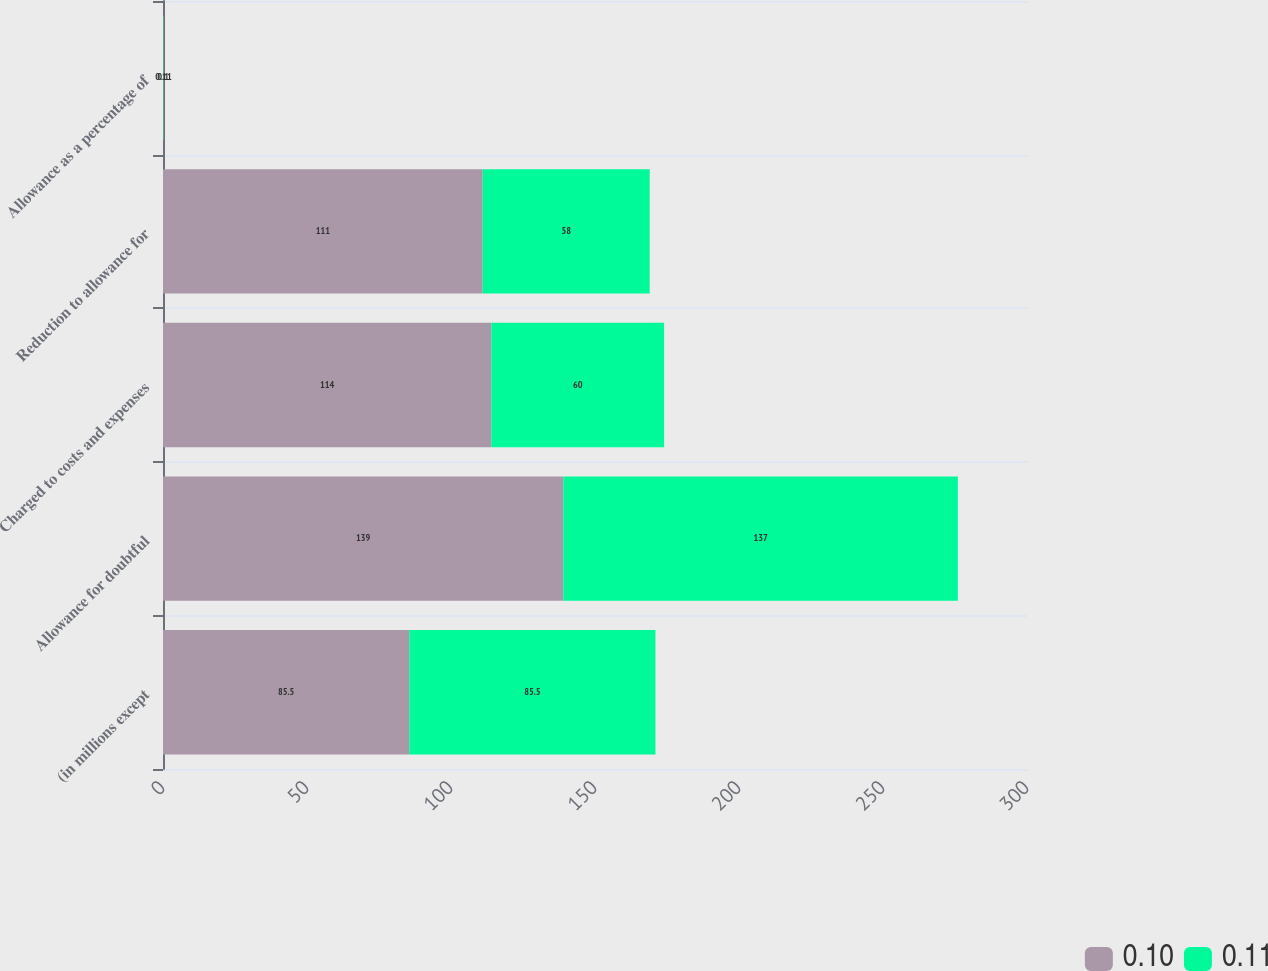Convert chart. <chart><loc_0><loc_0><loc_500><loc_500><stacked_bar_chart><ecel><fcel>(in millions except<fcel>Allowance for doubtful<fcel>Charged to costs and expenses<fcel>Reduction to allowance for<fcel>Allowance as a percentage of<nl><fcel>0.1<fcel>85.5<fcel>139<fcel>114<fcel>111<fcel>0.1<nl><fcel>0.11<fcel>85.5<fcel>137<fcel>60<fcel>58<fcel>0.11<nl></chart> 